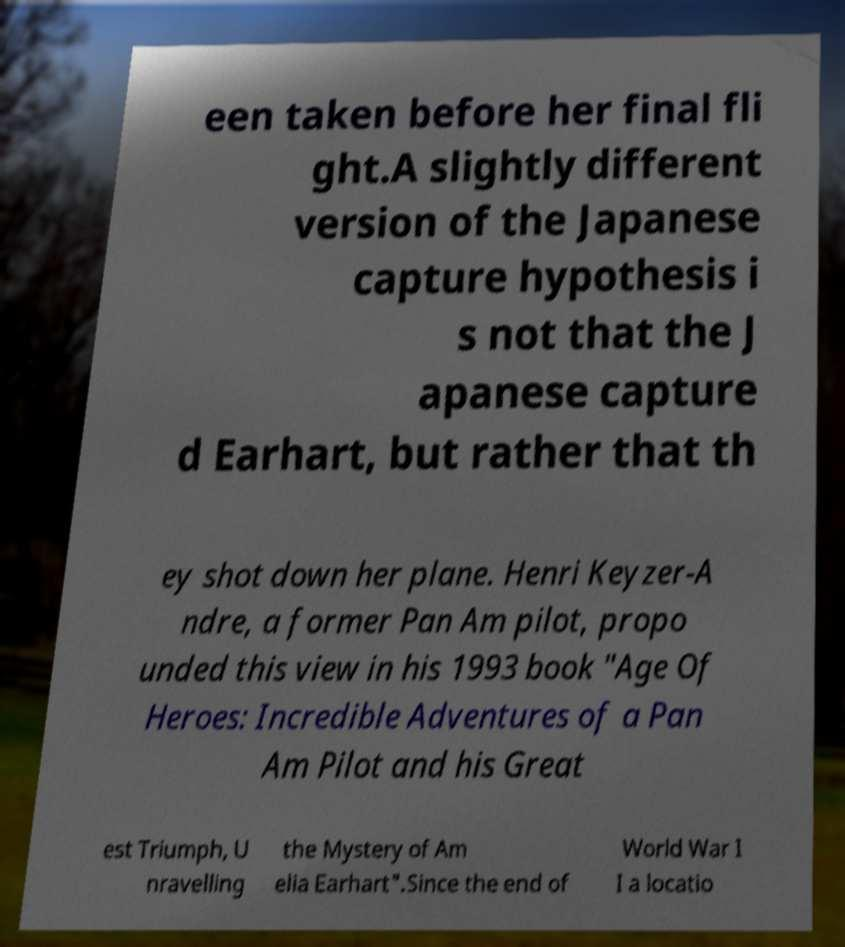Could you assist in decoding the text presented in this image and type it out clearly? een taken before her final fli ght.A slightly different version of the Japanese capture hypothesis i s not that the J apanese capture d Earhart, but rather that th ey shot down her plane. Henri Keyzer-A ndre, a former Pan Am pilot, propo unded this view in his 1993 book "Age Of Heroes: Incredible Adventures of a Pan Am Pilot and his Great est Triumph, U nravelling the Mystery of Am elia Earhart".Since the end of World War I I a locatio 